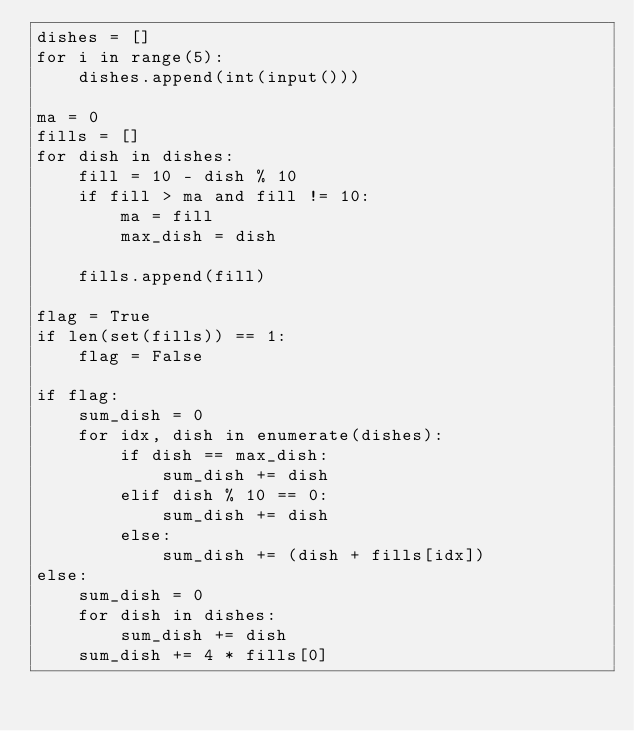<code> <loc_0><loc_0><loc_500><loc_500><_Python_>dishes = []
for i in range(5):
    dishes.append(int(input()))
    
ma = 0
fills = []
for dish in dishes:
    fill = 10 - dish % 10
    if fill > ma and fill != 10:
        ma = fill
        max_dish = dish
    
    fills.append(fill)

flag = True
if len(set(fills)) == 1:
    flag = False

if flag:
    sum_dish = 0
    for idx, dish in enumerate(dishes):
        if dish == max_dish:
            sum_dish += dish
        elif dish % 10 == 0:
            sum_dish += dish
        else:
            sum_dish += (dish + fills[idx])
else:
    sum_dish = 0
    for dish in dishes:
        sum_dish += dish
    sum_dish += 4 * fills[0]</code> 